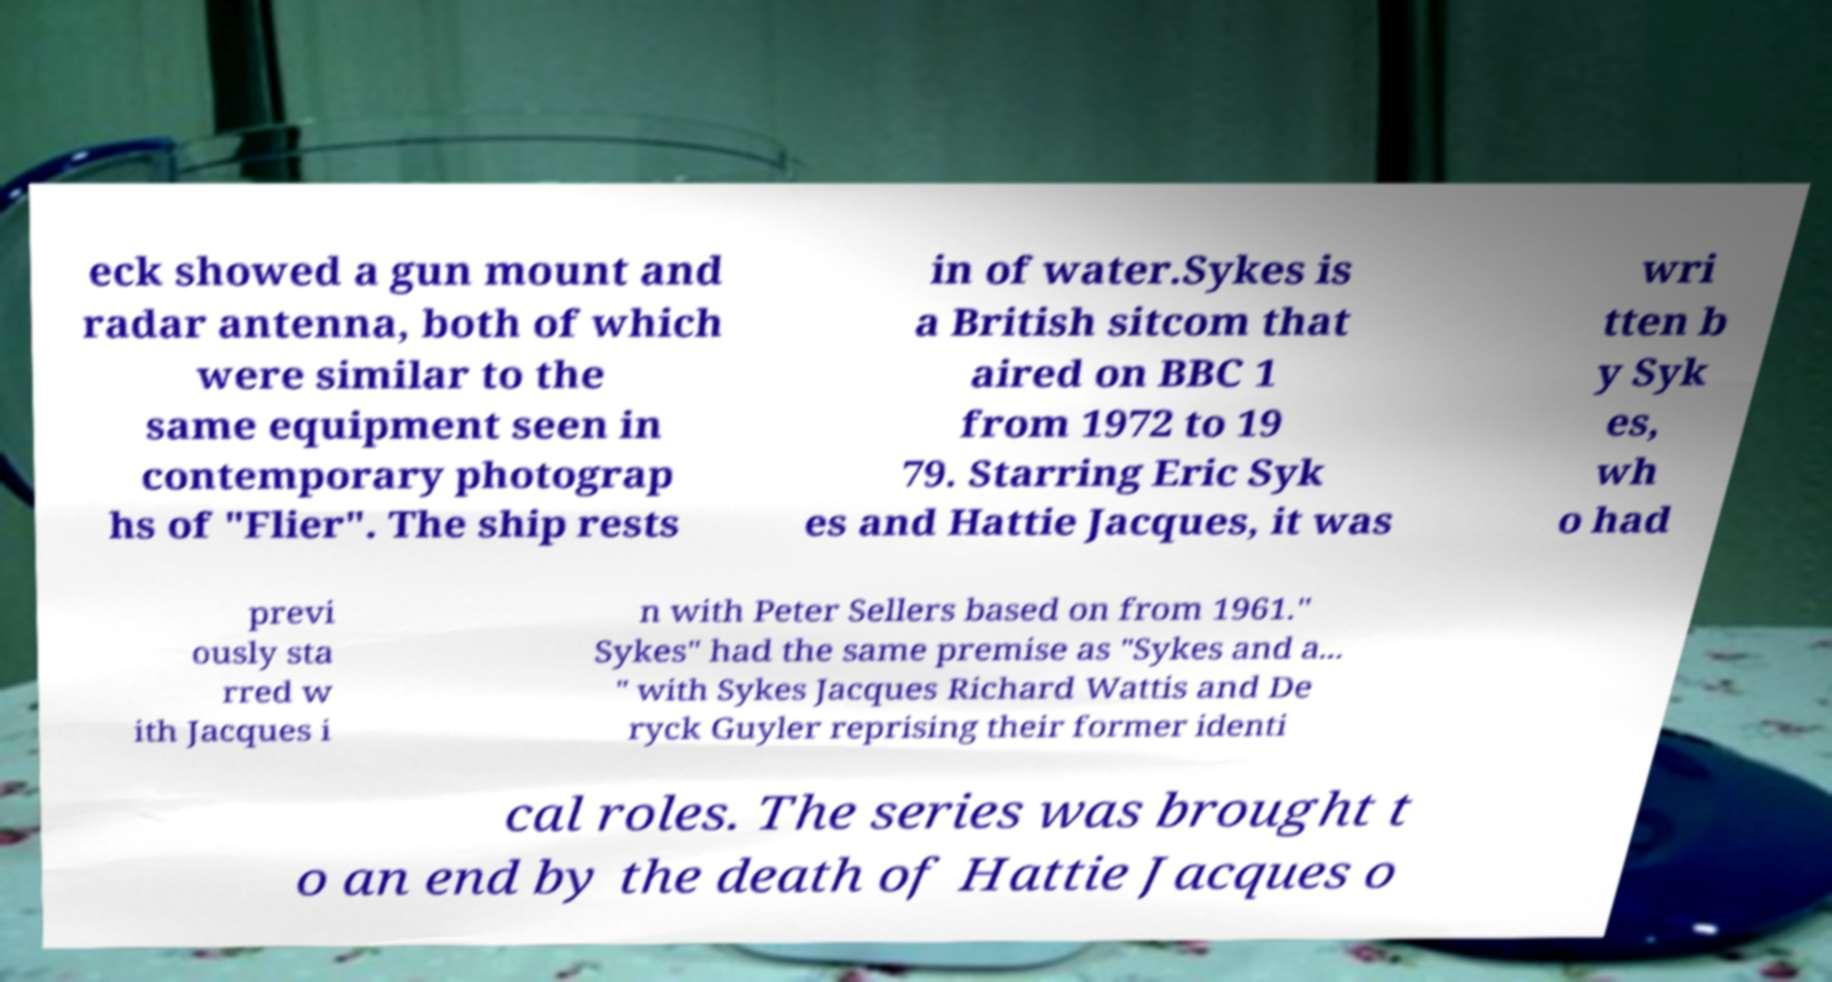Can you accurately transcribe the text from the provided image for me? eck showed a gun mount and radar antenna, both of which were similar to the same equipment seen in contemporary photograp hs of "Flier". The ship rests in of water.Sykes is a British sitcom that aired on BBC 1 from 1972 to 19 79. Starring Eric Syk es and Hattie Jacques, it was wri tten b y Syk es, wh o had previ ously sta rred w ith Jacques i n with Peter Sellers based on from 1961." Sykes" had the same premise as "Sykes and a... " with Sykes Jacques Richard Wattis and De ryck Guyler reprising their former identi cal roles. The series was brought t o an end by the death of Hattie Jacques o 